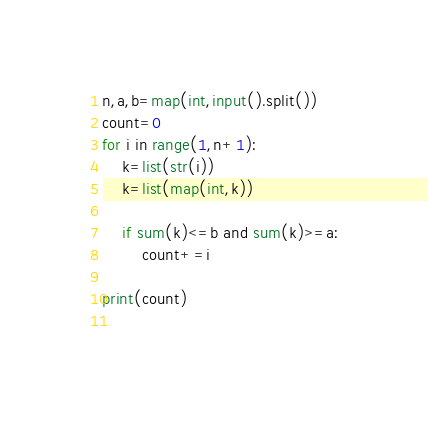<code> <loc_0><loc_0><loc_500><loc_500><_Python_>n,a,b=map(int,input().split())
count=0
for i in range(1,n+1):
    k=list(str(i))
    k=list(map(int,k))
    
    if sum(k)<=b and sum(k)>=a:
        count+=i

print(count)
    
</code> 